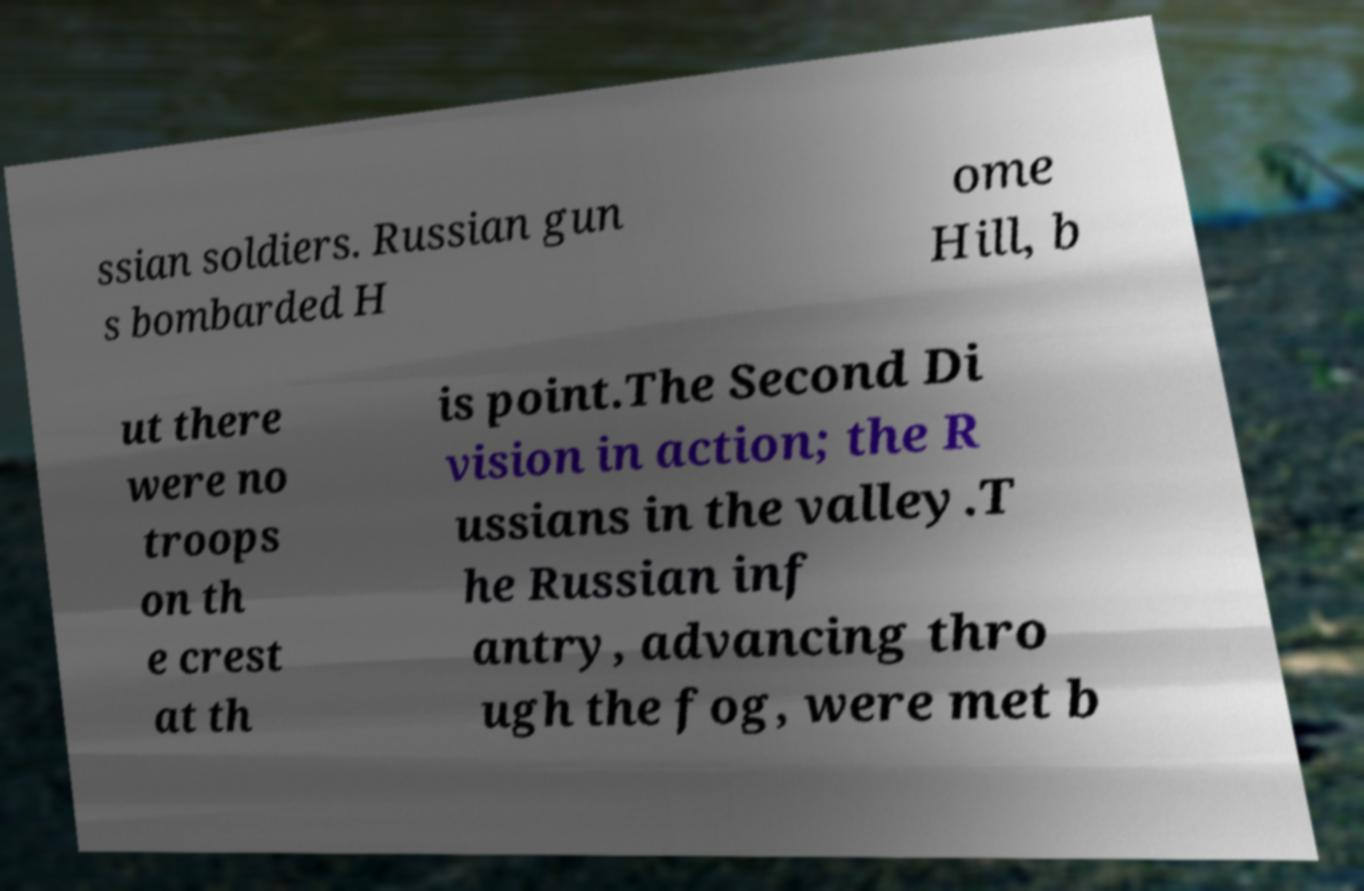I need the written content from this picture converted into text. Can you do that? ssian soldiers. Russian gun s bombarded H ome Hill, b ut there were no troops on th e crest at th is point.The Second Di vision in action; the R ussians in the valley.T he Russian inf antry, advancing thro ugh the fog, were met b 